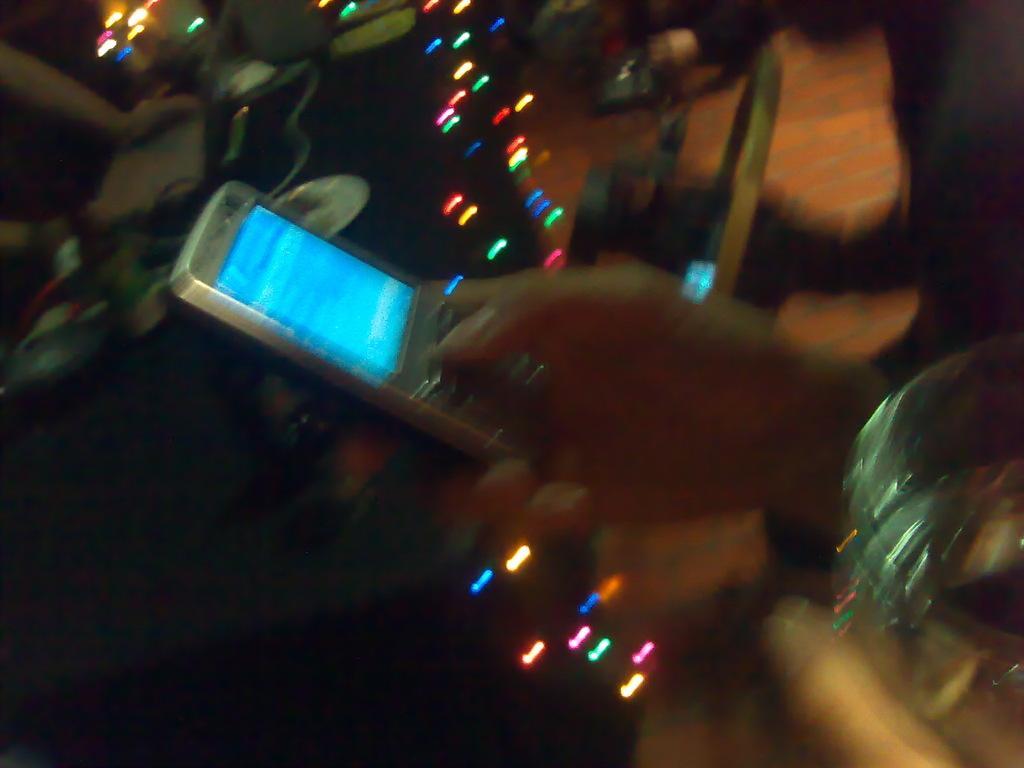Could you give a brief overview of what you see in this image? In this image we can see a person holding an object. There are many objects in the image. There are few lights in the image. There is a blur background in the image. 